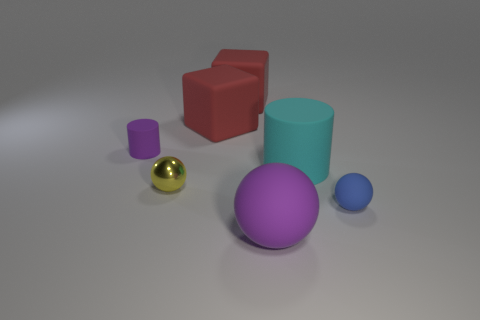Does the tiny matte thing that is to the left of the tiny blue thing have the same shape as the tiny yellow object?
Keep it short and to the point. No. There is a shiny ball that is the same size as the blue rubber thing; what color is it?
Your response must be concise. Yellow. What number of things are there?
Make the answer very short. 7. Are the purple thing right of the yellow shiny sphere and the small purple cylinder made of the same material?
Your response must be concise. Yes. What is the big thing that is both in front of the tiny matte cylinder and behind the big ball made of?
Ensure brevity in your answer.  Rubber. What is the size of the ball that is the same color as the small cylinder?
Offer a very short reply. Large. There is a cylinder that is right of the tiny rubber thing behind the cyan cylinder; what is it made of?
Your response must be concise. Rubber. What size is the matte cylinder behind the big rubber object that is on the right side of the purple matte object that is in front of the small blue ball?
Your answer should be very brief. Small. How many large red blocks are made of the same material as the big cyan thing?
Ensure brevity in your answer.  2. The small ball that is left of the matte ball on the left side of the tiny rubber ball is what color?
Provide a short and direct response. Yellow. 